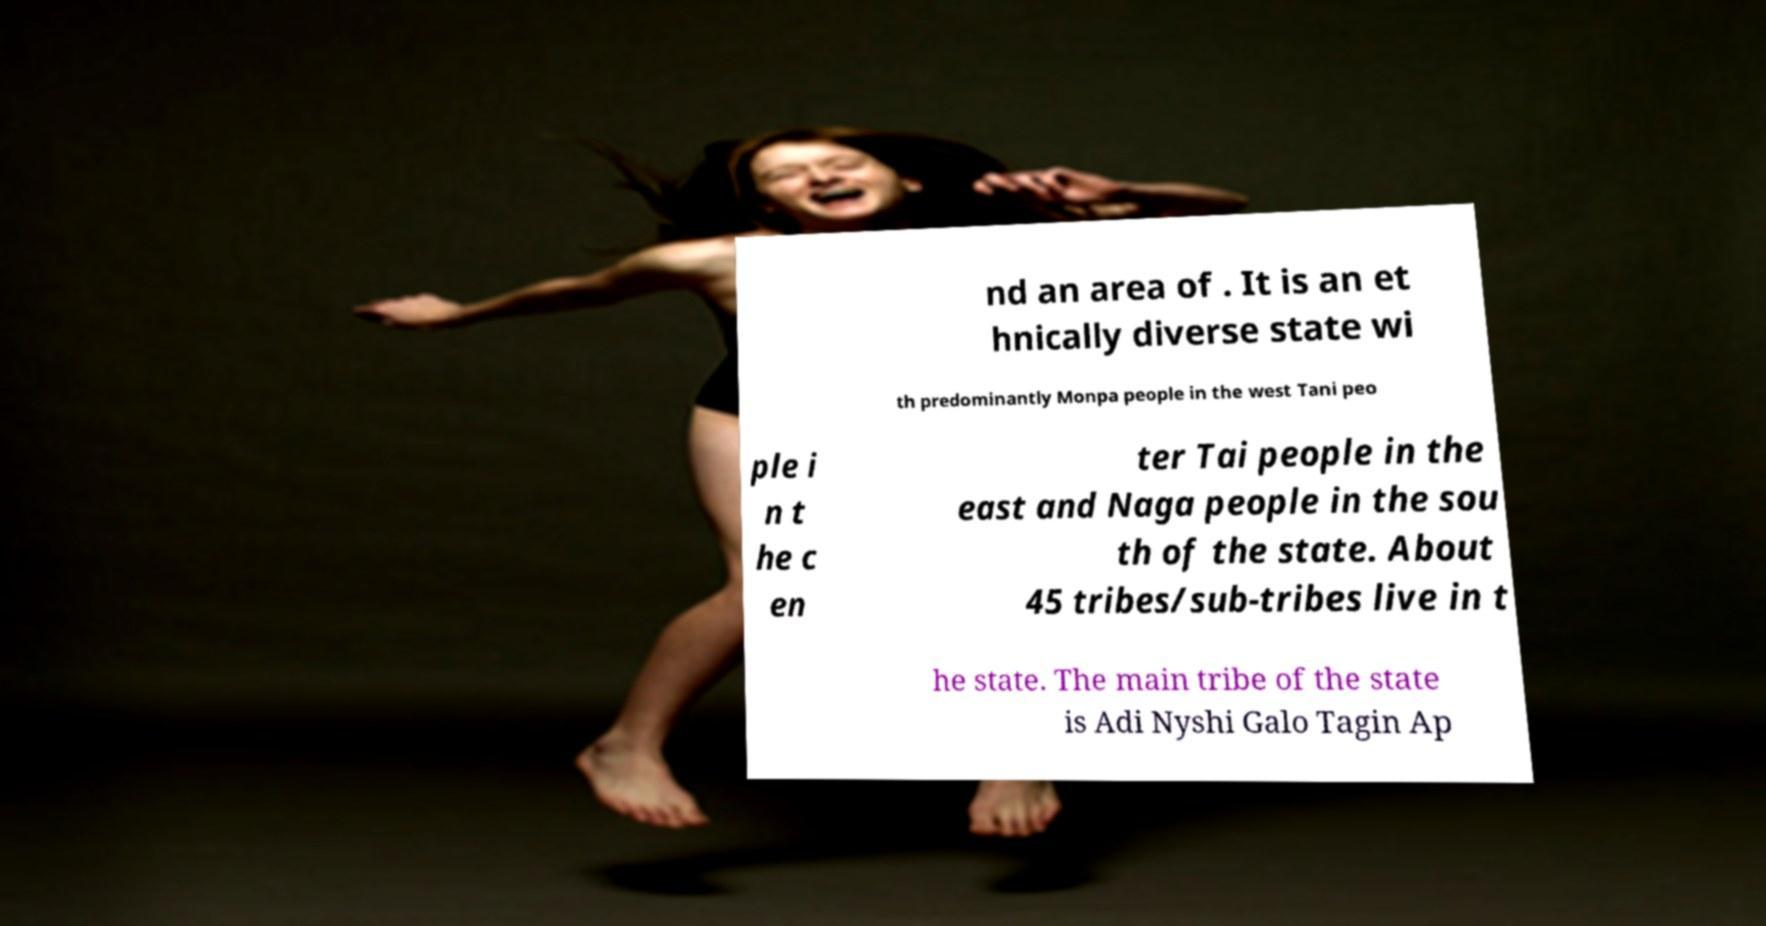Can you read and provide the text displayed in the image?This photo seems to have some interesting text. Can you extract and type it out for me? nd an area of . It is an et hnically diverse state wi th predominantly Monpa people in the west Tani peo ple i n t he c en ter Tai people in the east and Naga people in the sou th of the state. About 45 tribes/sub-tribes live in t he state. The main tribe of the state is Adi Nyshi Galo Tagin Ap 